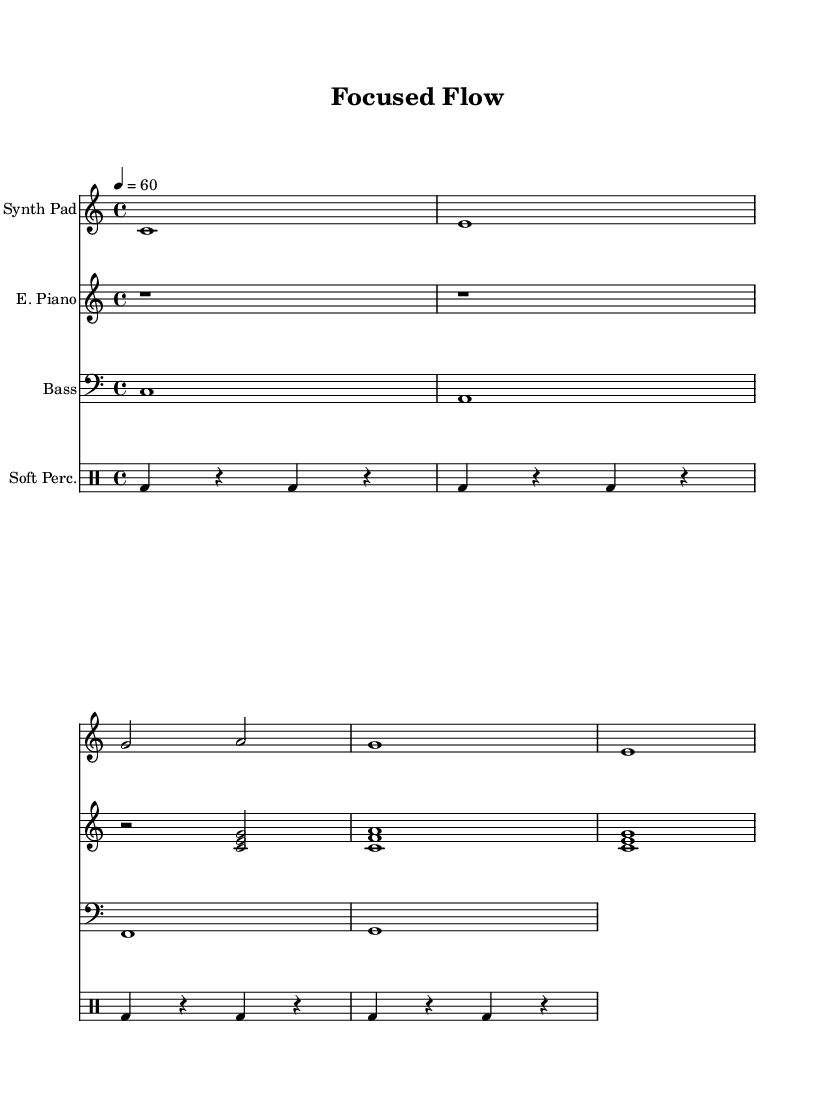What is the key signature of this music? The key signature is C major, which has no sharps or flats.
Answer: C major What is the time signature of this music? The time signature is indicated at the beginning of the score and is a measure of how many beats are in a measure; here, it shows that there are four beats per measure.
Answer: 4/4 What is the tempo marking for this piece? The tempo marking is written at the start of the music, indicating that each quarter note is to be played at a speed of sixty beats per minute.
Answer: 60 How many measures are in the synth pad part? By counting the number of vertical lines (bar lines) in the synth pad part, and considering the first bar does not count towards this total, we can determine that it contains a total of five measures.
Answer: 5 Which instrument has the highest pitch range in this score? The synth pad part, given it is written in treble clef and has higher sounding notes compared to the other instruments which are written in bass clef and include lower ranges.
Answer: Synth Pad Identify the rhythm used in the percussion part. The percussion part primarily uses a bass drum pattern with quarter note beats on the downbeat followed by rests, indicating a steady repetitive rhythm ideal for establishing a foundation in ambient soundscapes.
Answer: Bass drum with quarter notes What role does the electric piano play in this piece? The electric piano provides harmonic support with chords that fill the harmony and contribute to creating the ambient soundscape feeling by enhancing the melodic line.
Answer: Harmonic support 